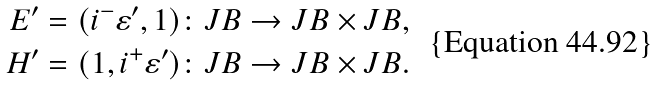Convert formula to latex. <formula><loc_0><loc_0><loc_500><loc_500>E ^ { \prime } = ( i ^ { - } \varepsilon ^ { \prime } , 1 ) & \colon J B \to J B \times J B , \\ H ^ { \prime } = ( 1 , i ^ { + } \varepsilon ^ { \prime } ) & \colon J B \to J B \times J B .</formula> 